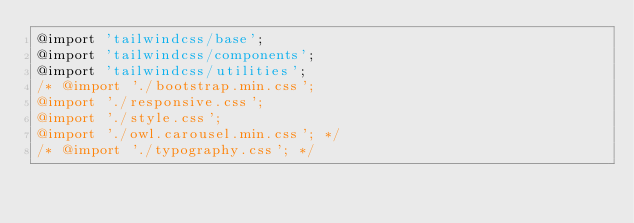<code> <loc_0><loc_0><loc_500><loc_500><_CSS_>@import 'tailwindcss/base';
@import 'tailwindcss/components';
@import 'tailwindcss/utilities';
/* @import './bootstrap.min.css';
@import './responsive.css';
@import './style.css';
@import './owl.carousel.min.css'; */
/* @import './typography.css'; */
</code> 